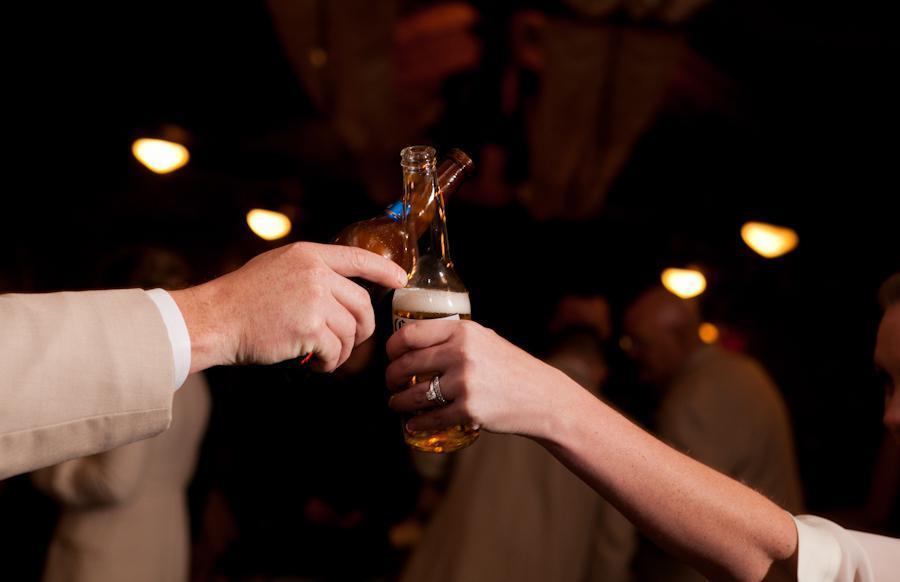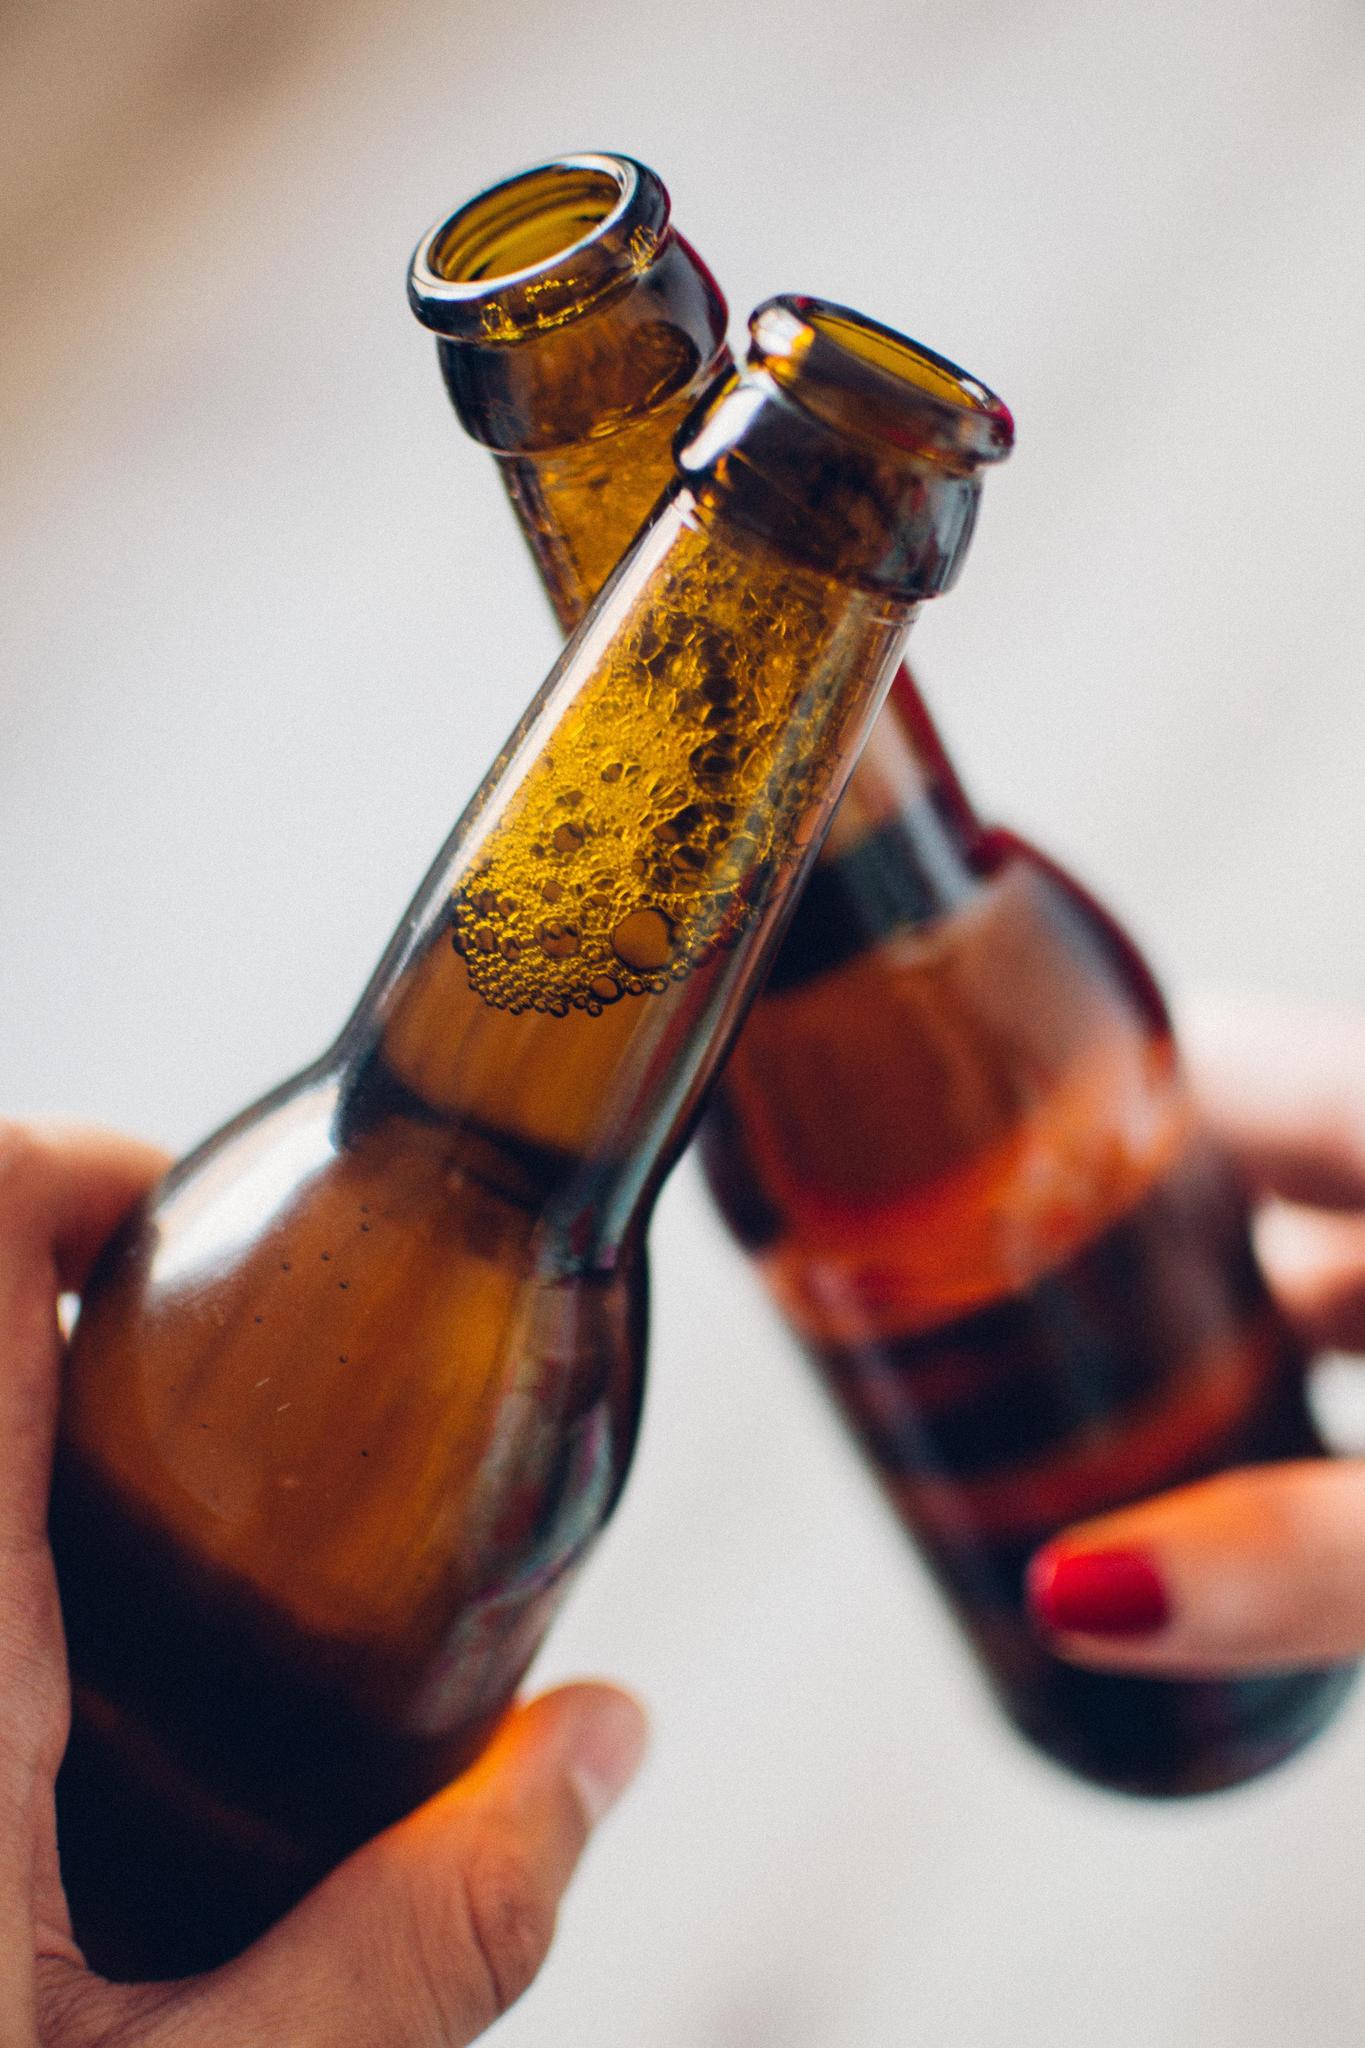The first image is the image on the left, the second image is the image on the right. Examine the images to the left and right. Is the description "A woman is smiling and looking to the left in the left image of the pair." accurate? Answer yes or no. No. The first image is the image on the left, the second image is the image on the right. Considering the images on both sides, is "The right image shows two hands clinking two beer bottles together." valid? Answer yes or no. Yes. 